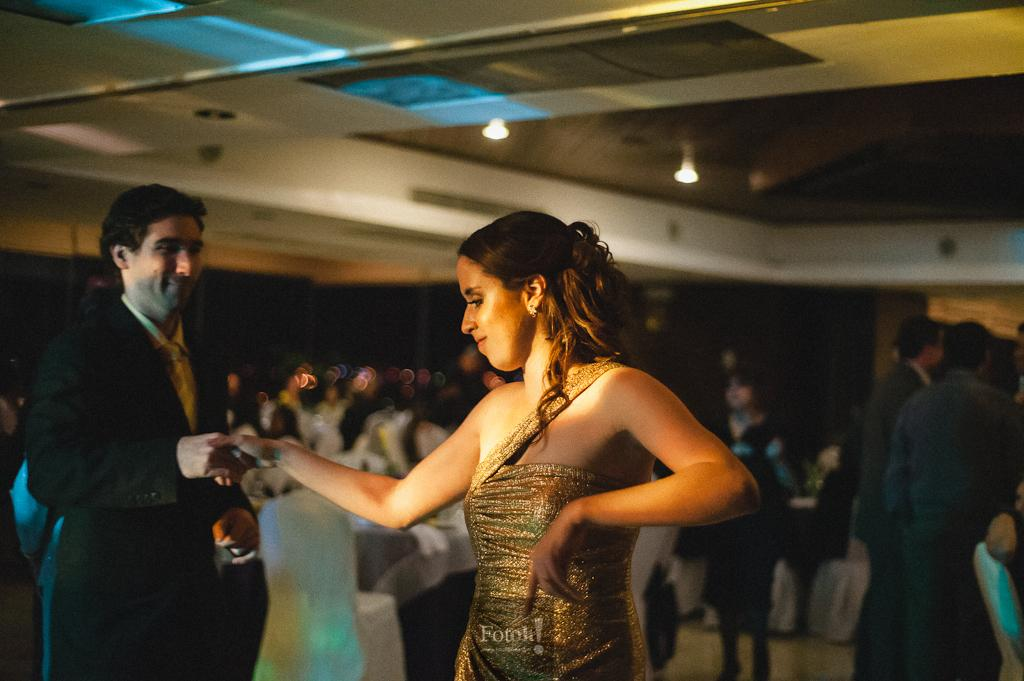How many people are in the image? There are two people in the image: a man and a woman. What are the two people doing in the image? The man is holding the woman's hand. What type of event might be taking place in the image? The scene appears to be a party. Can you describe the background of the two people? The background of the two people is blurred. What type of trade is taking place between the man and the woman in the image? There is no trade taking place between the man and the woman in the image; they are simply holding hands. Can you see any mittens on the man's or woman's hands in the image? There are no mittens present in the image; both individuals are holding hands without any additional accessories. 